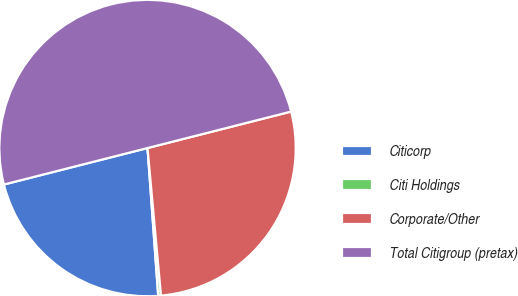Convert chart to OTSL. <chart><loc_0><loc_0><loc_500><loc_500><pie_chart><fcel>Citicorp<fcel>Citi Holdings<fcel>Corporate/Other<fcel>Total Citigroup (pretax)<nl><fcel>22.19%<fcel>0.3%<fcel>27.51%<fcel>50.0%<nl></chart> 